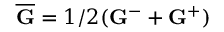<formula> <loc_0><loc_0><loc_500><loc_500>\overline { G } = 1 / 2 ( { G } ^ { - } + { G } ^ { + } )</formula> 